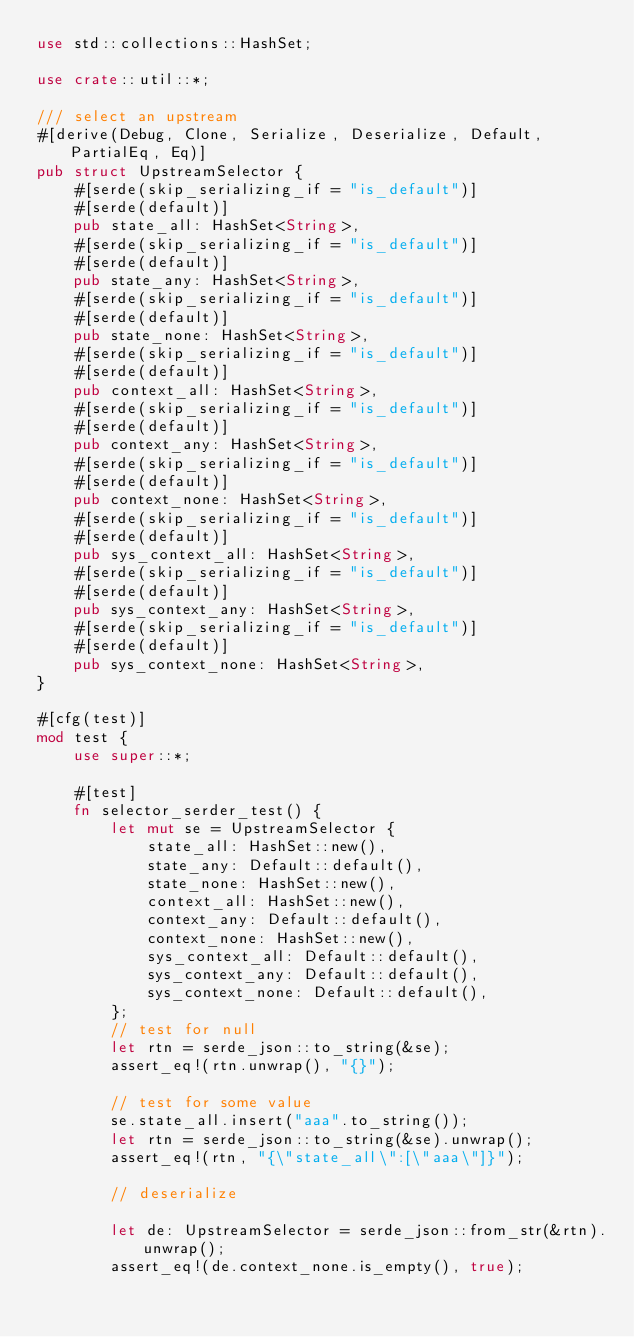<code> <loc_0><loc_0><loc_500><loc_500><_Rust_>use std::collections::HashSet;

use crate::util::*;

/// select an upstream
#[derive(Debug, Clone, Serialize, Deserialize, Default, PartialEq, Eq)]
pub struct UpstreamSelector {
    #[serde(skip_serializing_if = "is_default")]
    #[serde(default)]
    pub state_all: HashSet<String>,
    #[serde(skip_serializing_if = "is_default")]
    #[serde(default)]
    pub state_any: HashSet<String>,
    #[serde(skip_serializing_if = "is_default")]
    #[serde(default)]
    pub state_none: HashSet<String>,
    #[serde(skip_serializing_if = "is_default")]
    #[serde(default)]
    pub context_all: HashSet<String>,
    #[serde(skip_serializing_if = "is_default")]
    #[serde(default)]
    pub context_any: HashSet<String>,
    #[serde(skip_serializing_if = "is_default")]
    #[serde(default)]
    pub context_none: HashSet<String>,
    #[serde(skip_serializing_if = "is_default")]
    #[serde(default)]
    pub sys_context_all: HashSet<String>,
    #[serde(skip_serializing_if = "is_default")]
    #[serde(default)]
    pub sys_context_any: HashSet<String>,
    #[serde(skip_serializing_if = "is_default")]
    #[serde(default)]
    pub sys_context_none: HashSet<String>,
}

#[cfg(test)]
mod test {
    use super::*;

    #[test]
    fn selector_serder_test() {
        let mut se = UpstreamSelector {
            state_all: HashSet::new(),
            state_any: Default::default(),
            state_none: HashSet::new(),
            context_all: HashSet::new(),
            context_any: Default::default(),
            context_none: HashSet::new(),
            sys_context_all: Default::default(),
            sys_context_any: Default::default(),
            sys_context_none: Default::default(),
        };
        // test for null
        let rtn = serde_json::to_string(&se);
        assert_eq!(rtn.unwrap(), "{}");

        // test for some value
        se.state_all.insert("aaa".to_string());
        let rtn = serde_json::to_string(&se).unwrap();
        assert_eq!(rtn, "{\"state_all\":[\"aaa\"]}");

        // deserialize

        let de: UpstreamSelector = serde_json::from_str(&rtn).unwrap();
        assert_eq!(de.context_none.is_empty(), true);</code> 